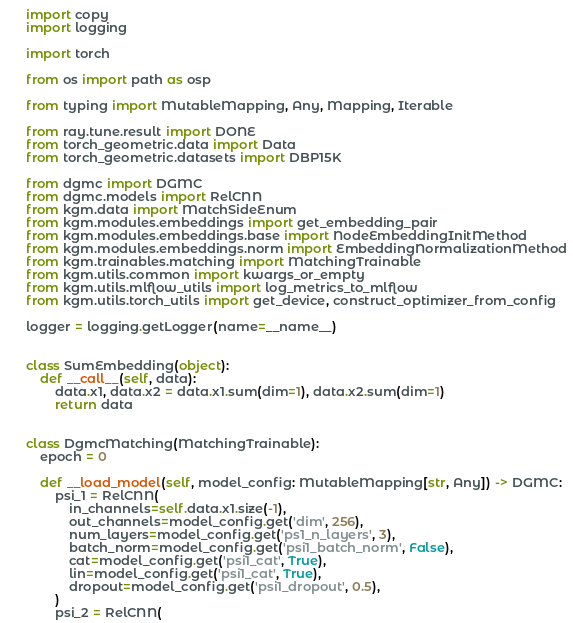<code> <loc_0><loc_0><loc_500><loc_500><_Python_>import copy
import logging

import torch

from os import path as osp

from typing import MutableMapping, Any, Mapping, Iterable

from ray.tune.result import DONE
from torch_geometric.data import Data
from torch_geometric.datasets import DBP15K

from dgmc import DGMC
from dgmc.models import RelCNN
from kgm.data import MatchSideEnum
from kgm.modules.embeddings import get_embedding_pair
from kgm.modules.embeddings.base import NodeEmbeddingInitMethod
from kgm.modules.embeddings.norm import EmbeddingNormalizationMethod
from kgm.trainables.matching import MatchingTrainable
from kgm.utils.common import kwargs_or_empty
from kgm.utils.mlflow_utils import log_metrics_to_mlflow
from kgm.utils.torch_utils import get_device, construct_optimizer_from_config

logger = logging.getLogger(name=__name__)


class SumEmbedding(object):
    def __call__(self, data):
        data.x1, data.x2 = data.x1.sum(dim=1), data.x2.sum(dim=1)
        return data


class DgmcMatching(MatchingTrainable):
    epoch = 0

    def __load_model(self, model_config: MutableMapping[str, Any]) -> DGMC:
        psi_1 = RelCNN(
            in_channels=self.data.x1.size(-1),
            out_channels=model_config.get('dim', 256),
            num_layers=model_config.get('ps1_n_layers', 3),
            batch_norm=model_config.get('psi1_batch_norm', False),
            cat=model_config.get('psi1_cat', True),
            lin=model_config.get('psi1_cat', True),
            dropout=model_config.get('psi1_dropout', 0.5),
        )
        psi_2 = RelCNN(</code> 